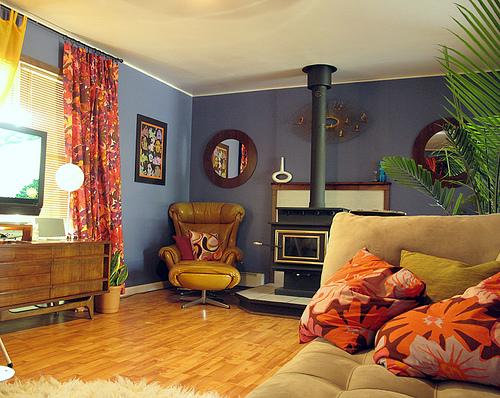Is this expertly designed or just thrown together?
Answer briefly. Expertly designed. Is there a clock in the room?
Keep it brief. No. Does the living room contain an electric fireplace or wood-burning stove?
Give a very brief answer. Wood burning stove. Is there a fire in the fireplace?
Concise answer only. No. 